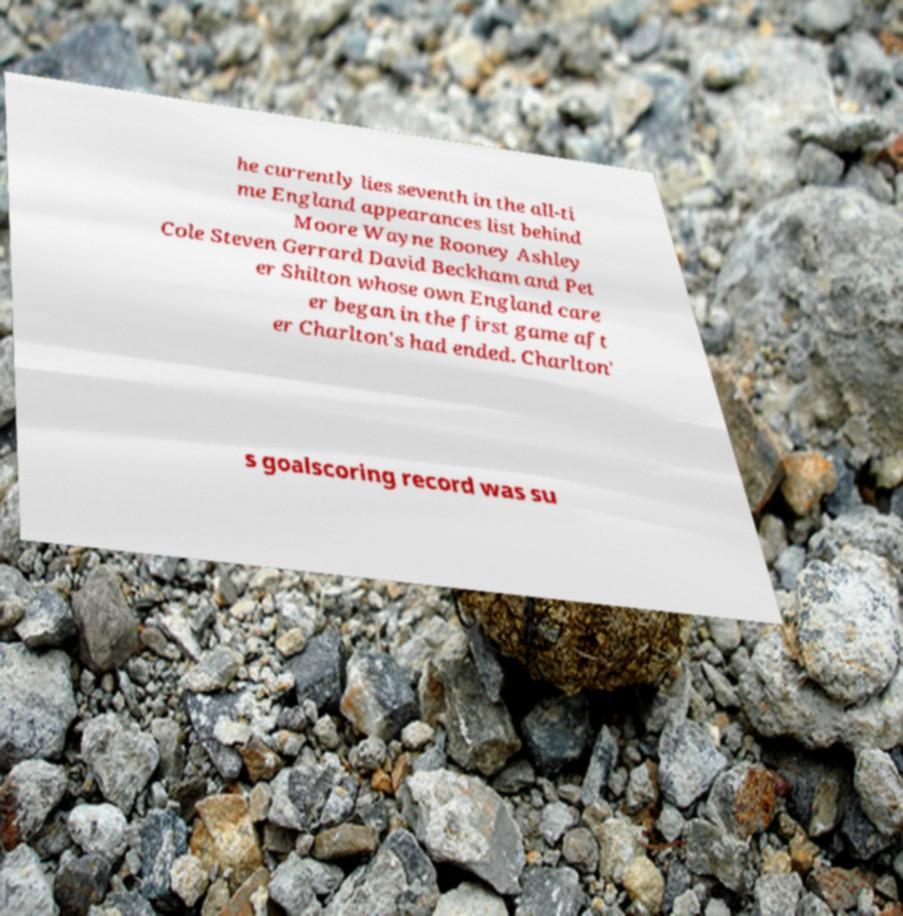For documentation purposes, I need the text within this image transcribed. Could you provide that? he currently lies seventh in the all-ti me England appearances list behind Moore Wayne Rooney Ashley Cole Steven Gerrard David Beckham and Pet er Shilton whose own England care er began in the first game aft er Charlton's had ended. Charlton' s goalscoring record was su 